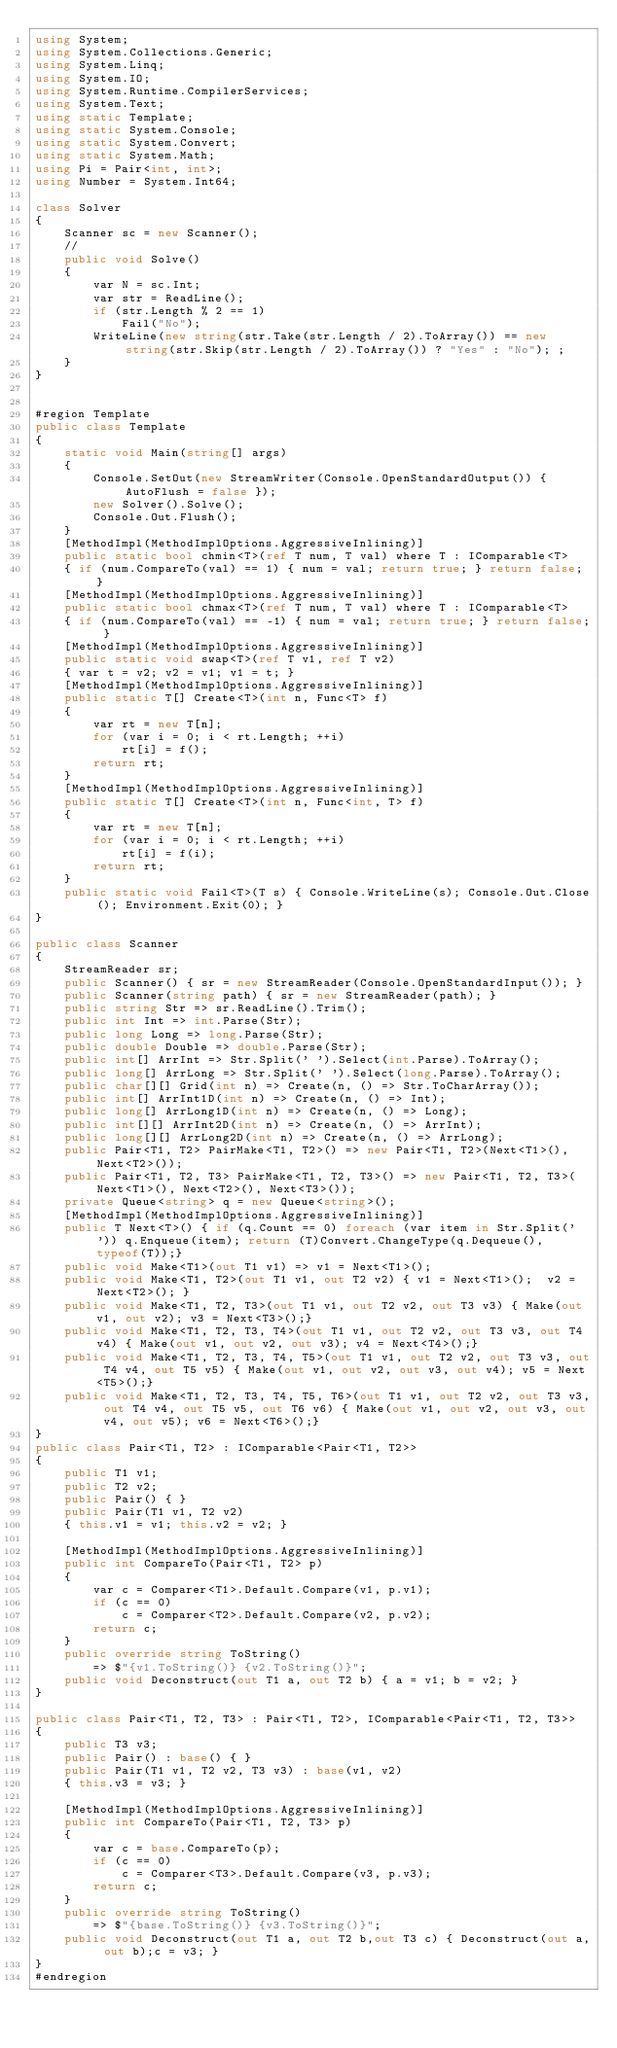<code> <loc_0><loc_0><loc_500><loc_500><_C#_>using System;
using System.Collections.Generic;
using System.Linq;
using System.IO;
using System.Runtime.CompilerServices;
using System.Text;
using static Template;
using static System.Console;
using static System.Convert;
using static System.Math;
using Pi = Pair<int, int>;
using Number = System.Int64;

class Solver
{
    Scanner sc = new Scanner();
    //
    public void Solve()
    {
        var N = sc.Int;
        var str = ReadLine();
        if (str.Length % 2 == 1)
            Fail("No");
        WriteLine(new string(str.Take(str.Length / 2).ToArray()) == new string(str.Skip(str.Length / 2).ToArray()) ? "Yes" : "No"); ;
    }
}


#region Template
public class Template
{
    static void Main(string[] args)
    {
        Console.SetOut(new StreamWriter(Console.OpenStandardOutput()) { AutoFlush = false });
        new Solver().Solve();
        Console.Out.Flush();
    }
    [MethodImpl(MethodImplOptions.AggressiveInlining)]
    public static bool chmin<T>(ref T num, T val) where T : IComparable<T>
    { if (num.CompareTo(val) == 1) { num = val; return true; } return false; }
    [MethodImpl(MethodImplOptions.AggressiveInlining)]
    public static bool chmax<T>(ref T num, T val) where T : IComparable<T>
    { if (num.CompareTo(val) == -1) { num = val; return true; } return false; }
    [MethodImpl(MethodImplOptions.AggressiveInlining)]
    public static void swap<T>(ref T v1, ref T v2)
    { var t = v2; v2 = v1; v1 = t; }
    [MethodImpl(MethodImplOptions.AggressiveInlining)]
    public static T[] Create<T>(int n, Func<T> f)
    {
        var rt = new T[n];
        for (var i = 0; i < rt.Length; ++i)
            rt[i] = f();
        return rt;
    }
    [MethodImpl(MethodImplOptions.AggressiveInlining)]
    public static T[] Create<T>(int n, Func<int, T> f)
    {
        var rt = new T[n];
        for (var i = 0; i < rt.Length; ++i)
            rt[i] = f(i);
        return rt;
    }
    public static void Fail<T>(T s) { Console.WriteLine(s); Console.Out.Close(); Environment.Exit(0); }
}

public class Scanner
{
    StreamReader sr;
    public Scanner() { sr = new StreamReader(Console.OpenStandardInput()); }
    public Scanner(string path) { sr = new StreamReader(path); }
    public string Str => sr.ReadLine().Trim();
    public int Int => int.Parse(Str);
    public long Long => long.Parse(Str);
    public double Double => double.Parse(Str);
    public int[] ArrInt => Str.Split(' ').Select(int.Parse).ToArray();
    public long[] ArrLong => Str.Split(' ').Select(long.Parse).ToArray();
    public char[][] Grid(int n) => Create(n, () => Str.ToCharArray());
    public int[] ArrInt1D(int n) => Create(n, () => Int);
    public long[] ArrLong1D(int n) => Create(n, () => Long);
    public int[][] ArrInt2D(int n) => Create(n, () => ArrInt);
    public long[][] ArrLong2D(int n) => Create(n, () => ArrLong);
    public Pair<T1, T2> PairMake<T1, T2>() => new Pair<T1, T2>(Next<T1>(), Next<T2>());
    public Pair<T1, T2, T3> PairMake<T1, T2, T3>() => new Pair<T1, T2, T3>(Next<T1>(), Next<T2>(), Next<T3>());
    private Queue<string> q = new Queue<string>();
    [MethodImpl(MethodImplOptions.AggressiveInlining)]
    public T Next<T>() { if (q.Count == 0) foreach (var item in Str.Split(' ')) q.Enqueue(item); return (T)Convert.ChangeType(q.Dequeue(), typeof(T));}
    public void Make<T1>(out T1 v1) => v1 = Next<T1>();
    public void Make<T1, T2>(out T1 v1, out T2 v2) { v1 = Next<T1>();  v2 = Next<T2>(); }
    public void Make<T1, T2, T3>(out T1 v1, out T2 v2, out T3 v3) { Make(out v1, out v2); v3 = Next<T3>();}
    public void Make<T1, T2, T3, T4>(out T1 v1, out T2 v2, out T3 v3, out T4 v4) { Make(out v1, out v2, out v3); v4 = Next<T4>();}
    public void Make<T1, T2, T3, T4, T5>(out T1 v1, out T2 v2, out T3 v3, out T4 v4, out T5 v5) { Make(out v1, out v2, out v3, out v4); v5 = Next<T5>();}
    public void Make<T1, T2, T3, T4, T5, T6>(out T1 v1, out T2 v2, out T3 v3, out T4 v4, out T5 v5, out T6 v6) { Make(out v1, out v2, out v3, out v4, out v5); v6 = Next<T6>();}
}
public class Pair<T1, T2> : IComparable<Pair<T1, T2>>
{
    public T1 v1;
    public T2 v2;
    public Pair() { }
    public Pair(T1 v1, T2 v2)
    { this.v1 = v1; this.v2 = v2; }

    [MethodImpl(MethodImplOptions.AggressiveInlining)]
    public int CompareTo(Pair<T1, T2> p)
    {
        var c = Comparer<T1>.Default.Compare(v1, p.v1);
        if (c == 0)
            c = Comparer<T2>.Default.Compare(v2, p.v2);
        return c;
    }
    public override string ToString()
        => $"{v1.ToString()} {v2.ToString()}";
    public void Deconstruct(out T1 a, out T2 b) { a = v1; b = v2; }
}

public class Pair<T1, T2, T3> : Pair<T1, T2>, IComparable<Pair<T1, T2, T3>>
{
    public T3 v3;
    public Pair() : base() { }
    public Pair(T1 v1, T2 v2, T3 v3) : base(v1, v2)
    { this.v3 = v3; }

    [MethodImpl(MethodImplOptions.AggressiveInlining)]
    public int CompareTo(Pair<T1, T2, T3> p)
    {
        var c = base.CompareTo(p);
        if (c == 0)
            c = Comparer<T3>.Default.Compare(v3, p.v3);
        return c;
    }
    public override string ToString()
        => $"{base.ToString()} {v3.ToString()}";
    public void Deconstruct(out T1 a, out T2 b,out T3 c) { Deconstruct(out a, out b);c = v3; }
}
#endregion
</code> 